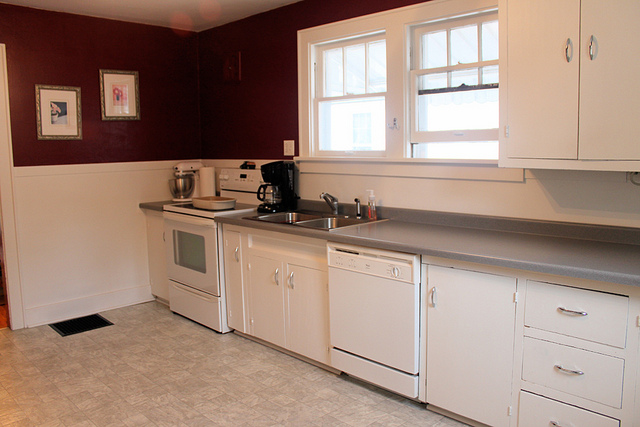What futuristic gadgets might one expect to find in a kitchen like this in 50 years? In 50 years, one might expect to find an array of advanced futuristic gadgets in this kitchen. Imagine a smart refrigerator that not only keeps track of inventory but also suggests recipes based on what you have and your dietary preferences. There could be an integrated cooking station with a holographic interface that provides step-by-step culinary guidance while also playing your favorite music or showing a cooking show. Self-cleaning countertops with built-in sanitizing technology might keep everything spotless. A robotic assistant could help with various chores, from prepping ingredients to organizing groceries. These innovations would transform the kitchen into a space of utmost convenience and innovation.  Pretend you're a chef cooking in this kitchen for a grand banquet. What dishes do you prepare? As a chef preparing for a grand banquet in this kitchen, the menu would be a culinary extravaganza. Starting with an amuse-bouche of smoked salmon with dill cream on cucumber slices, followed by a selection of appetizers such as saffron-infused arancini, mini bruschetta with heirloom tomatoes, and a delicate lobster bisque. For the main course, a slow-roasted beef tenderloin with a rich red wine reduction, served with truffle mashed potatoes and a medley of roasted seasonal vegetables. A vegetarian option could include a wild mushroom risotto with shaved parmesan. To conclude the meal, a dessert trio of chocolate fondant, vanilla bean panna cotta with berry compote, and a refreshing lemon sorbet. Each dish would be expertly crafted and beautifully presented, making the banquet a memorable feast for all the senses. 